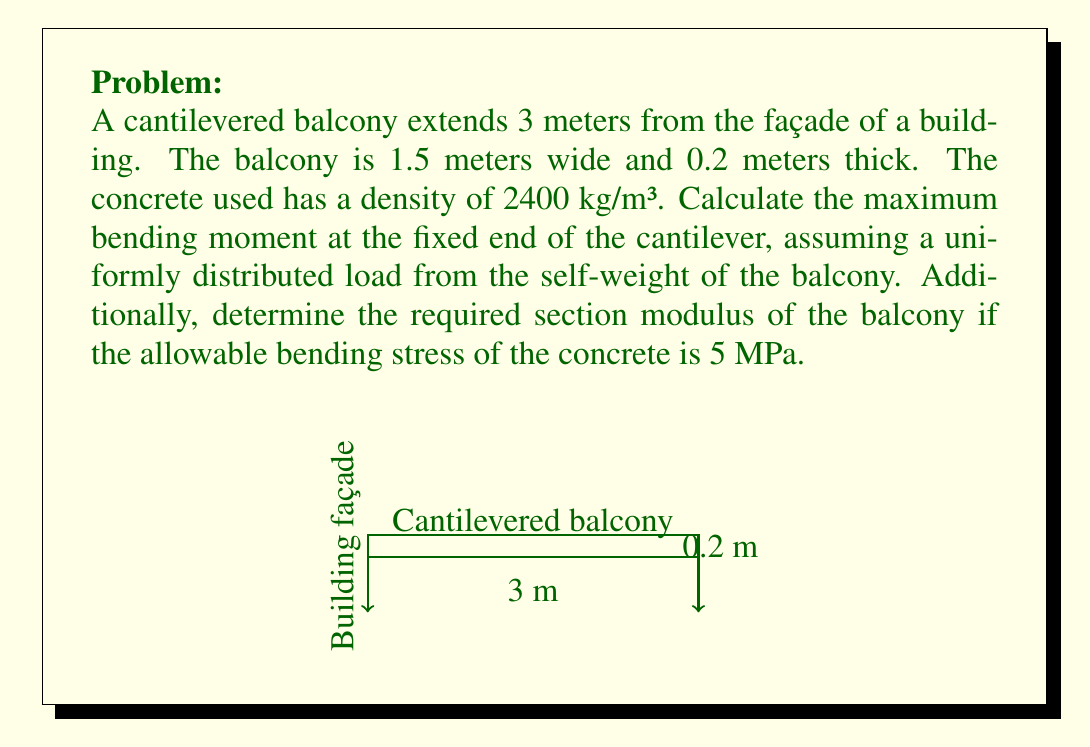Can you solve this math problem? To solve this problem, we'll follow these steps:

1. Calculate the volume of the balcony:
   $V = 3 \text{ m} \times 1.5 \text{ m} \times 0.2 \text{ m} = 0.9 \text{ m}^3$

2. Calculate the total weight of the balcony:
   $W = V \times \text{density} = 0.9 \text{ m}^3 \times 2400 \text{ kg/m}^3 = 2160 \text{ kg}$

3. Convert the weight to force:
   $F = W \times g = 2160 \text{ kg} \times 9.81 \text{ m/s}^2 = 21189.6 \text{ N} \approx 21190 \text{ N}$

4. Calculate the uniformly distributed load:
   $w = \frac{F}{\text{length}} = \frac{21190 \text{ N}}{3 \text{ m}} = 7063.33 \text{ N/m}$

5. Calculate the maximum bending moment at the fixed end:
   $M_{\text{max}} = \frac{wL^2}{2} = \frac{7063.33 \text{ N/m} \times (3 \text{ m})^2}{2} = 31785 \text{ N⋅m}$

6. Calculate the required section modulus:
   $S = \frac{M_{\text{max}}}{\sigma_{\text{allowable}}} = \frac{31785 \text{ N⋅m}}{5 \times 10^6 \text{ Pa}} = 0.006357 \text{ m}^3 = 6.357 \times 10^{-3} \text{ m}^3$

The maximum bending moment occurs at the fixed end of the cantilever, where the balcony meets the building façade. This is because the moment arm is longest at this point, creating the greatest rotational force.

The section modulus is a geometric property of the beam's cross-section that relates to its ability to resist bending. A larger section modulus indicates a stronger resistance to bending stresses.
Answer: Maximum bending moment: $M_{\text{max}} = 31785 \text{ N⋅m}$
Required section modulus: $S = 6.357 \times 10^{-3} \text{ m}^3$ 